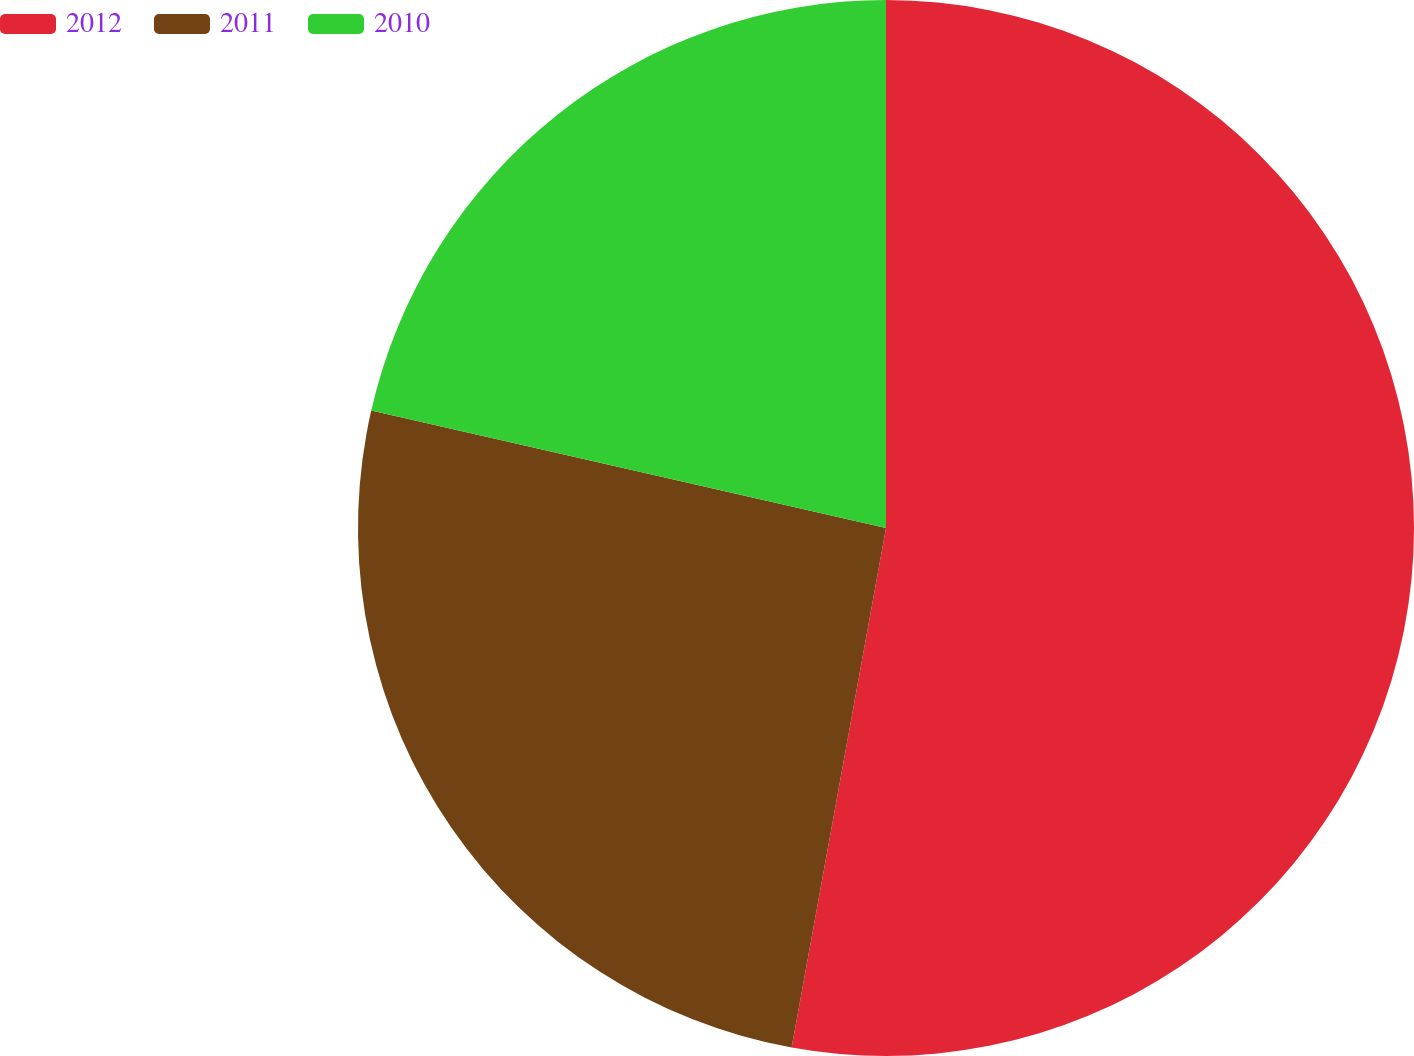Convert chart to OTSL. <chart><loc_0><loc_0><loc_500><loc_500><pie_chart><fcel>2012<fcel>2011<fcel>2010<nl><fcel>52.86%<fcel>25.71%<fcel>21.43%<nl></chart> 